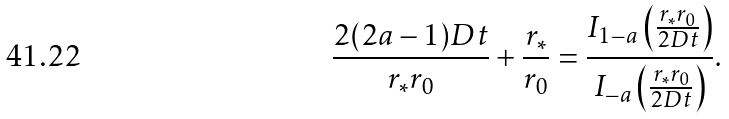<formula> <loc_0><loc_0><loc_500><loc_500>\frac { 2 ( 2 a - 1 ) D t } { r _ { * } r _ { 0 } } + \frac { r _ { * } } { r _ { 0 } } = \frac { I _ { 1 - a } \left ( \frac { r _ { * } r _ { 0 } } { 2 D t } \right ) } { I _ { - a } \left ( \frac { r _ { * } r _ { 0 } } { 2 D t } \right ) } .</formula> 